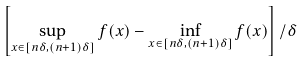<formula> <loc_0><loc_0><loc_500><loc_500>\left [ \sup _ { x \in [ n \delta , ( n + 1 ) \delta ] } f ( x ) - \inf _ { x \in [ n \delta , ( n + 1 ) \delta ] } f ( x ) \right ] / \delta</formula> 